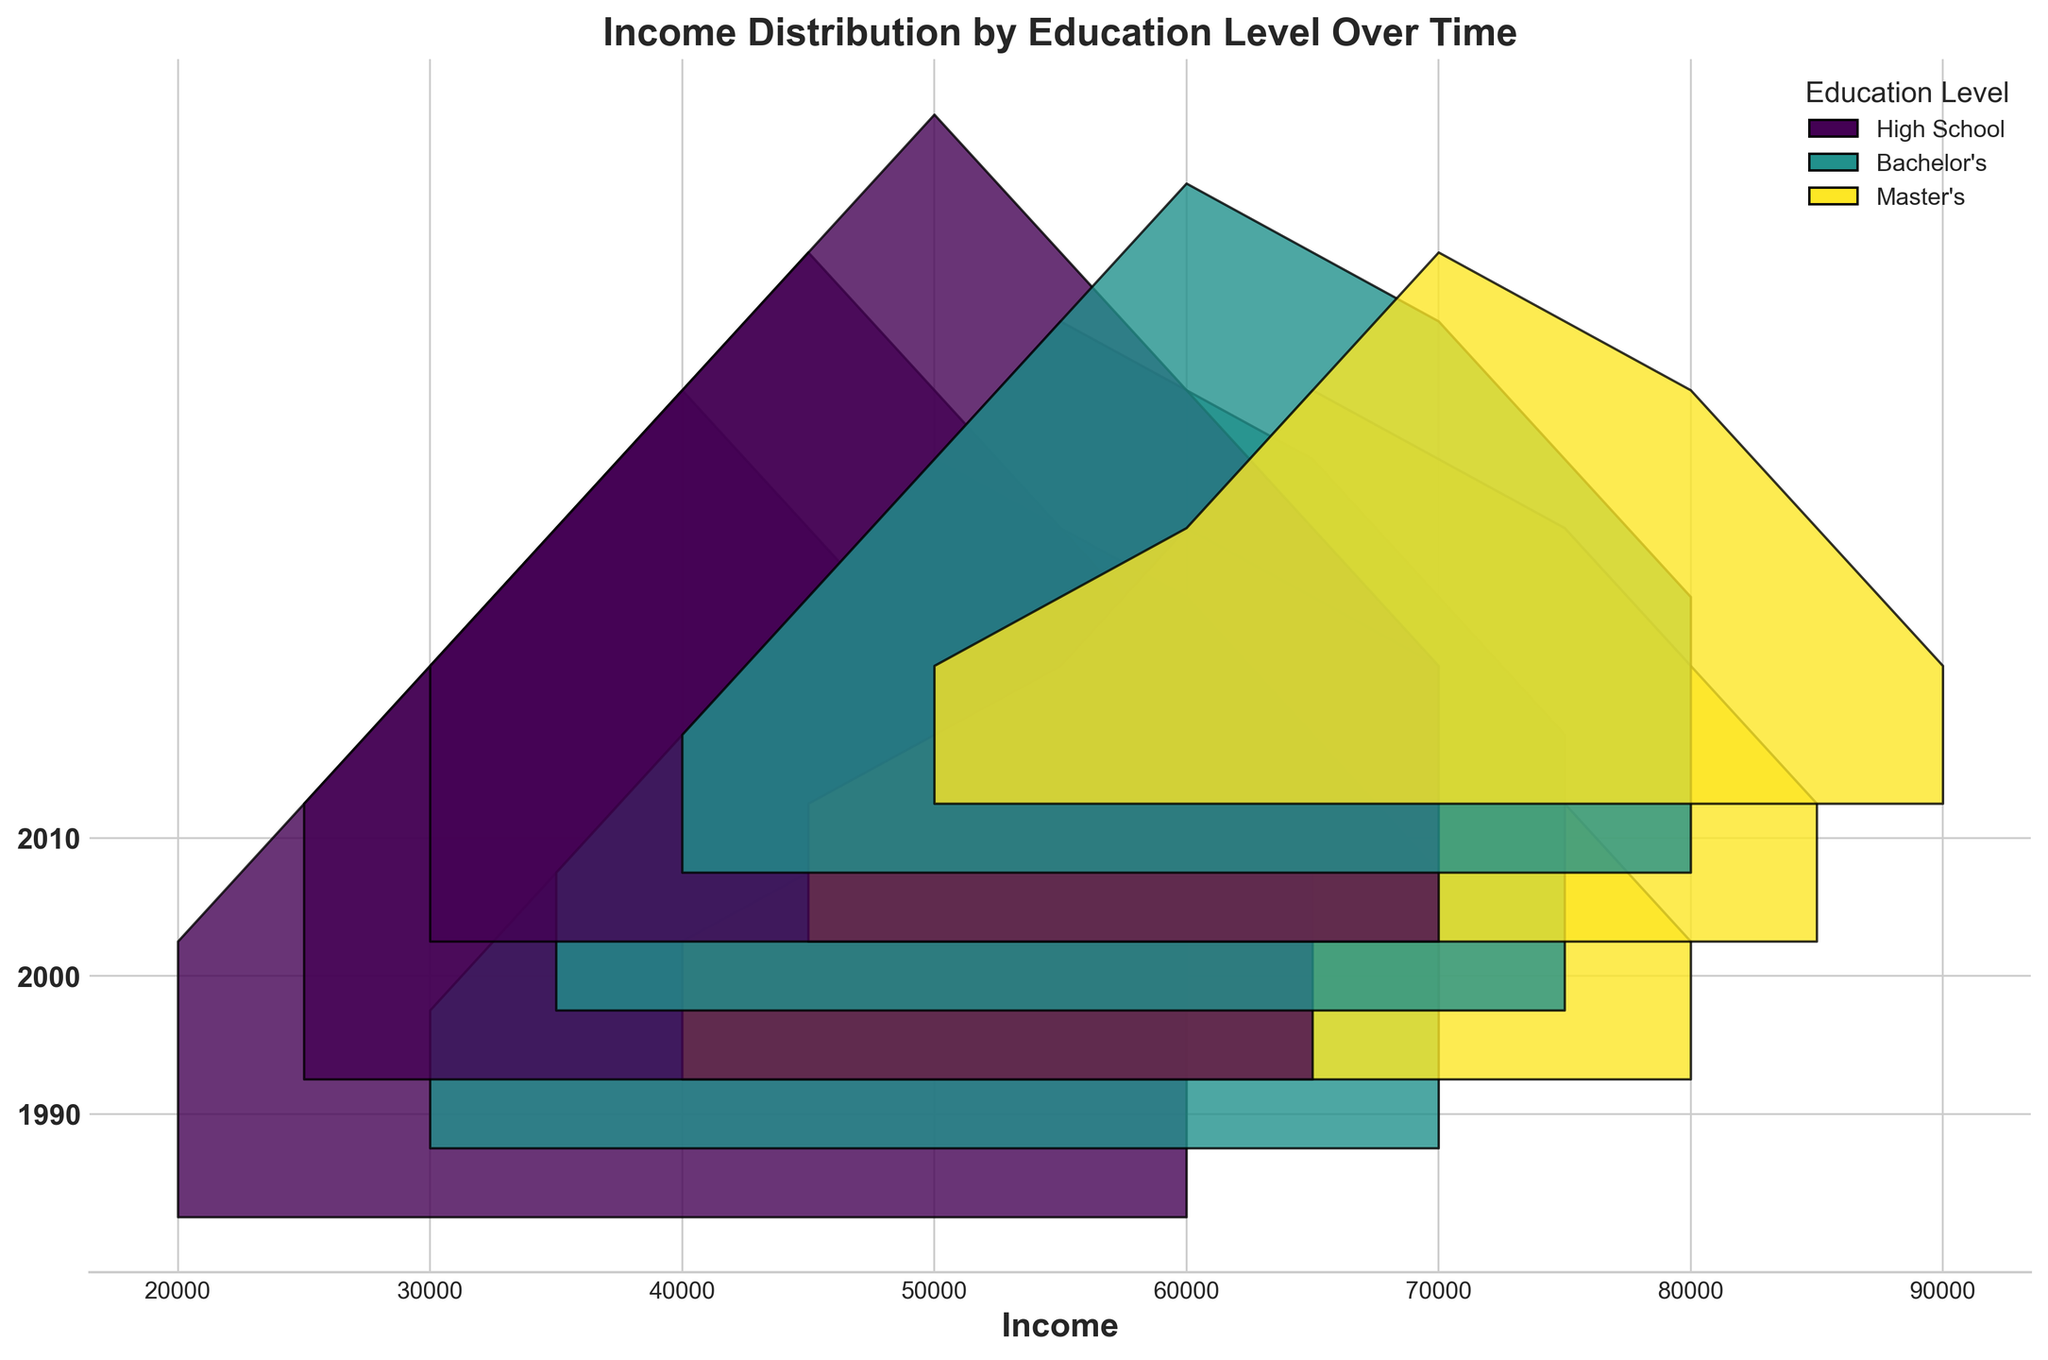What's the title of the plot? The title of the plot is displayed at the top of the figure. It provides a brief description of what the plot represents.
Answer: Income Distribution by Education Level Over Time Which education level has the highest income density in 2010? In 2010, the highest income density can be identified by looking at the peak value of the ridgeline for each education level. Among High School, Bachelor's, and Master's levels, we observe the highest peak.
Answer: High School How does the income distribution for high school graduates change from 1990 to 2010? By comparing the distribution curves for high school graduates in 1990 and 2010, we can observe shifts in peak positions and heights. In 1990, the peaks are around $40,000 and lower, while in 2010, they shift to higher income levels around $50,000.
Answer: The income distribution shifts to higher income levels Which education level shows the greatest increase in peak income density from 1990 to 2000? Compare the height (density) of the peaks for each education level between 1990 and 2000. The education level with the largest increase in the peak height represents the greatest increase in peak income density.
Answer: High School In which year is the median income for Bachelor's graduates highest? To find the highest median income for Bachelor's graduates over the years, compare the middle values of the income ranges in different years by visually inspecting the central tendency of the distributions.
Answer: 2010 What trend can be observed for Master's degree holders' income distribution from 1990 to 2010? By examining the ridgeline plots for Master's degree holders over the years, one can identify trends in shifts of income density peaks and changes in central density positions. There is a noticeable upward trend in peak income from 1990 to 2010.
Answer: It shows an upward trend How do Bachelor’s degree income distributions compare to High School graduates from 1990 to 2010? Compare the ridgeline curves of Bachelor's and High School graduates over the given years. Look for shifts in peaks and overlaps to understand relative increases or decreases in income densities.
Answer: Bachelor's distributions are generally shifted to higher incomes compared to High School graduates What is the lowest income for which Master's degree holders maintain a non-zero density across all years? Examine the ridgeline plots for Master's degree holders for each year and identify the lowest income value where the density line is above zero across all years.
Answer: $40,000 What's the overall trend in income distributions over time, regardless of education level? Analyze the direction in which the income density peaks move over the years across all education levels to determine if there's a general trend of increasing or decreasing income.
Answer: Generally, the distributions shift to higher incomes over time 